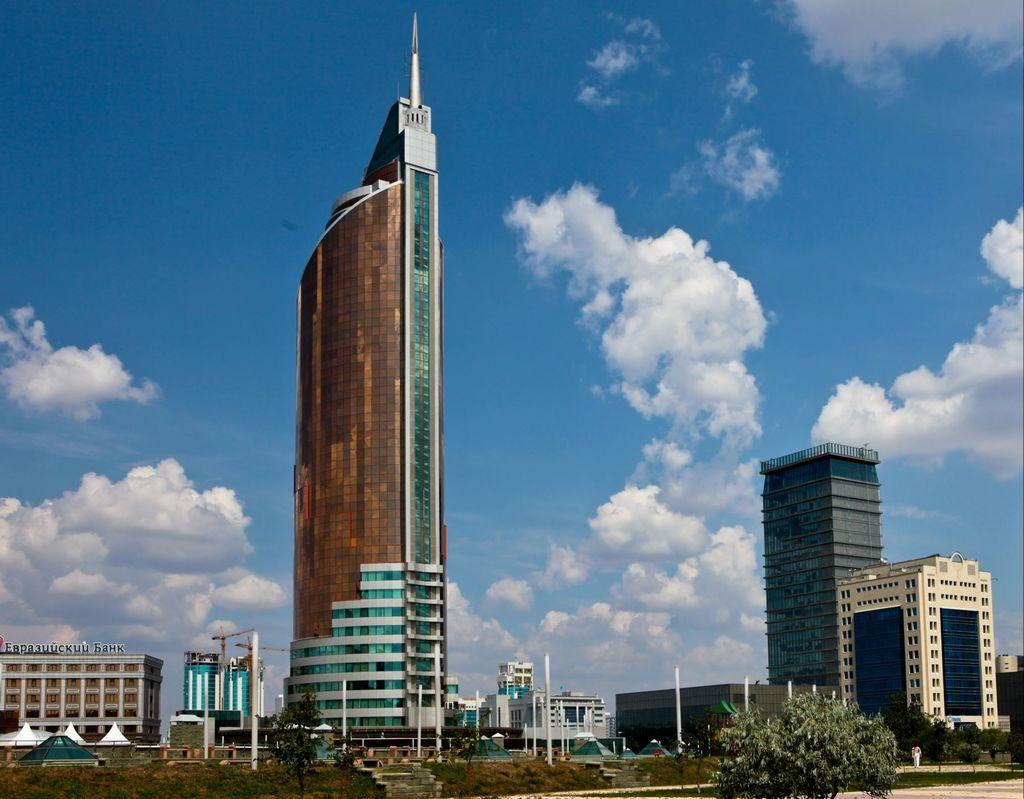What type of structures are present in the image? There are buildings in the image. What other natural elements can be seen in the image? There are trees in the image. What is visible in the background of the image? The sky is visible in the background of the image. How would you describe the sky in the image? The sky is clear and blue, with clouds visible. Where are the flowers being harvested for honey in the image? There are no flowers or honey present in the image; it features buildings, trees, and a clear blue sky with clouds. What type of competition is taking place in the image? There is no competition present in the image; it features buildings, trees, and a clear blue sky with clouds. 